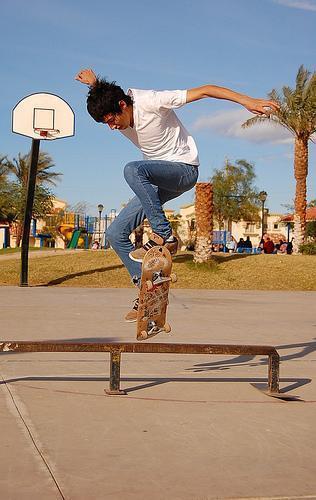How many skateboarders are there?
Give a very brief answer. 1. 